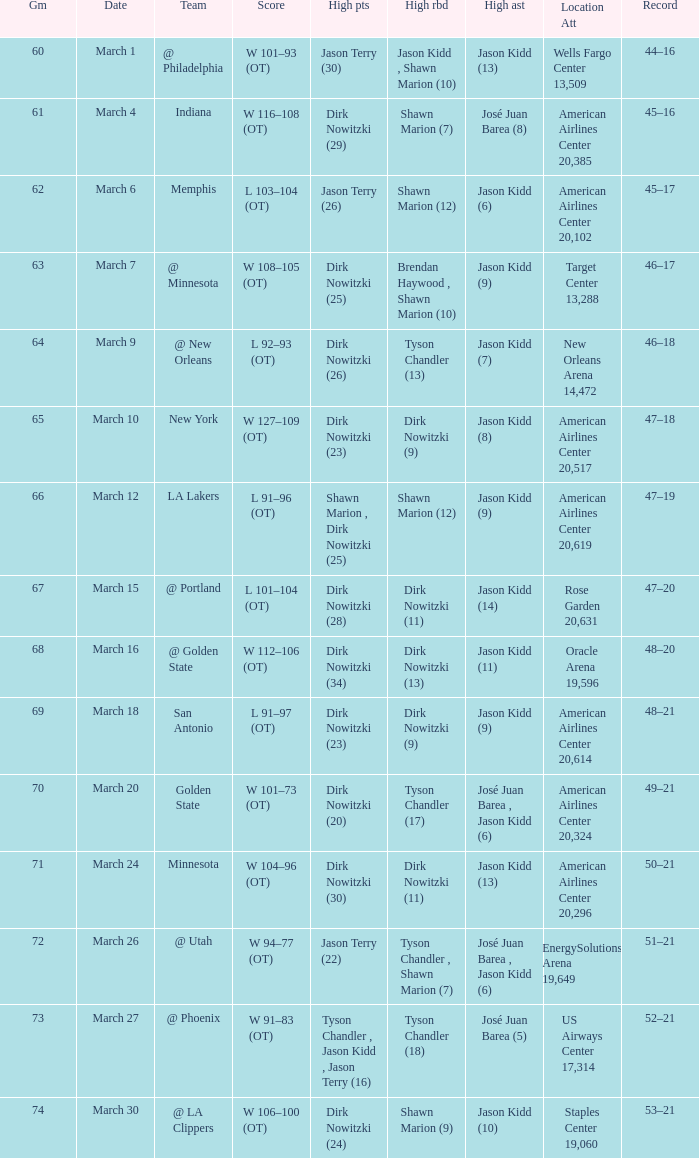Name the score for  josé juan barea (8) W 116–108 (OT). 